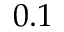<formula> <loc_0><loc_0><loc_500><loc_500>0 . 1</formula> 